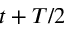Convert formula to latex. <formula><loc_0><loc_0><loc_500><loc_500>t + T / 2</formula> 